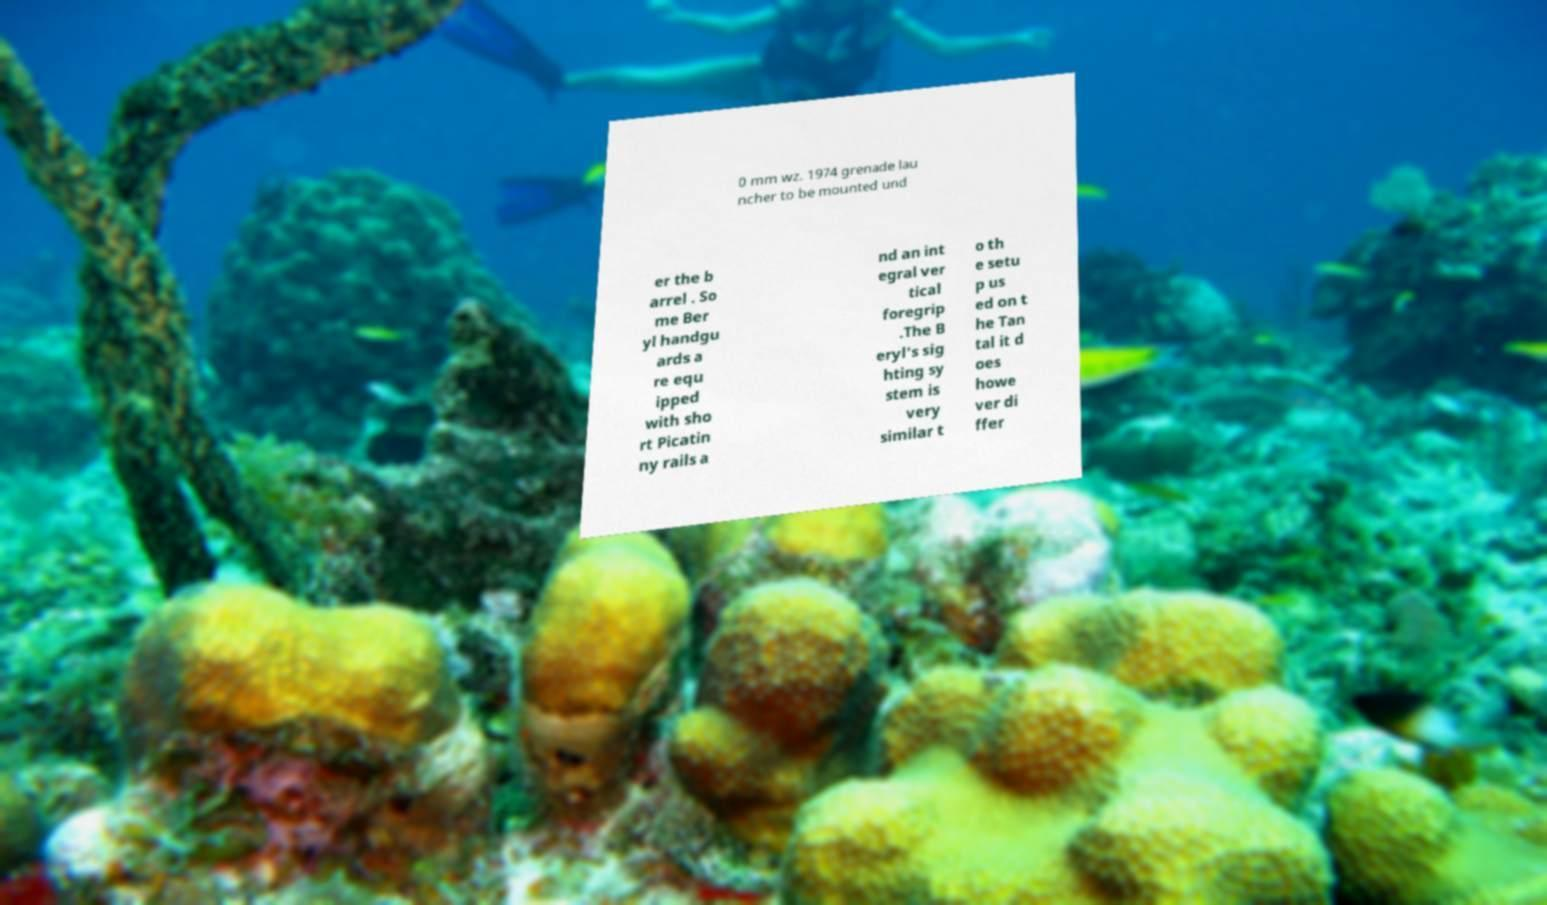Can you accurately transcribe the text from the provided image for me? 0 mm wz. 1974 grenade lau ncher to be mounted und er the b arrel . So me Ber yl handgu ards a re equ ipped with sho rt Picatin ny rails a nd an int egral ver tical foregrip .The B eryl's sig hting sy stem is very similar t o th e setu p us ed on t he Tan tal it d oes howe ver di ffer 